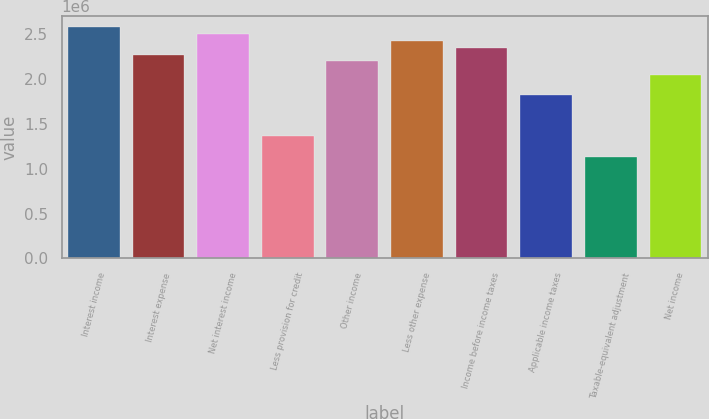Convert chart to OTSL. <chart><loc_0><loc_0><loc_500><loc_500><bar_chart><fcel>Interest income<fcel>Interest expense<fcel>Net interest income<fcel>Less provision for credit<fcel>Other income<fcel>Less other expense<fcel>Income before income taxes<fcel>Applicable income taxes<fcel>Taxable-equivalent adjustment<fcel>Net income<nl><fcel>2.57602e+06<fcel>2.27296e+06<fcel>2.50026e+06<fcel>1.36378e+06<fcel>2.1972e+06<fcel>2.42449e+06<fcel>2.34873e+06<fcel>1.81837e+06<fcel>1.13648e+06<fcel>2.04567e+06<nl></chart> 